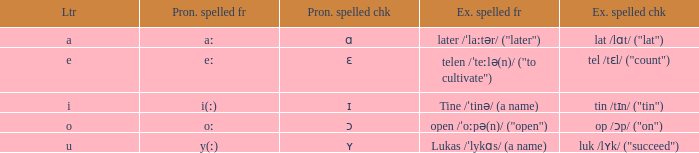What is Pronunciation Spelled Free, when Pronunciation Spelled Checked is "ɛ"? Eː. 